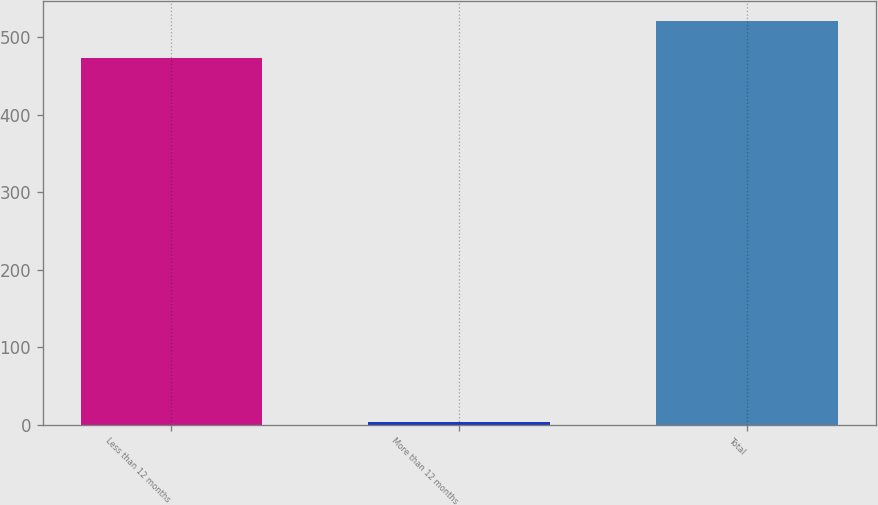Convert chart to OTSL. <chart><loc_0><loc_0><loc_500><loc_500><bar_chart><fcel>Less than 12 months<fcel>More than 12 months<fcel>Total<nl><fcel>474<fcel>4<fcel>521.4<nl></chart> 